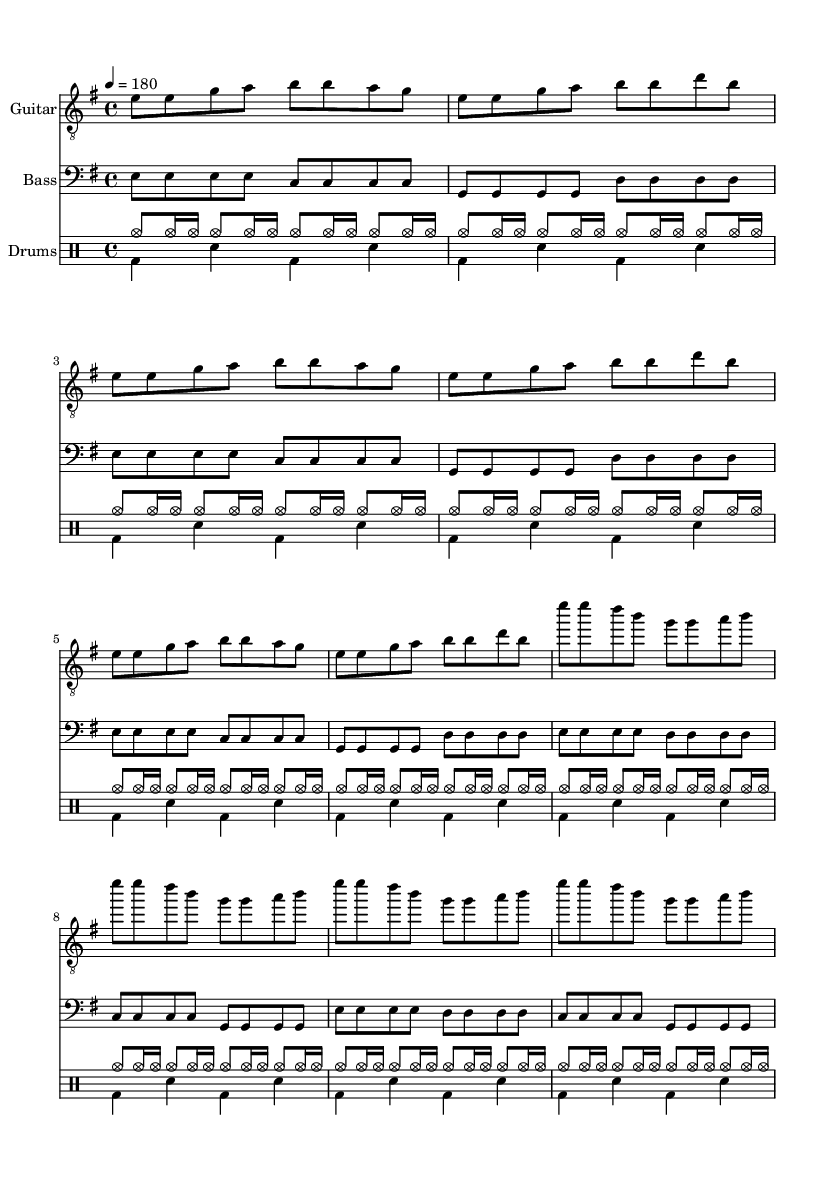What is the key signature of this music? The key signature is E minor, which contains one sharp (F#). This can be identified in the beginning of the music, where the key signature is indicated before the time signature.
Answer: E minor What is the time signature of the piece? The time signature is 4/4, as indicated in the score where it clearly shows the two numbers: 4 on top and 4 on the bottom. This means that there are four beats in a measure, and the quarter note gets one beat.
Answer: 4/4 What is the tempo marking for this music? The tempo marking is 180 beats per minute, indicated in the score at the beginning with the notation "4 = 180". This specifies the speed at which the music should be played.
Answer: 180 How many measures are in the chorus section? There are four measures in the chorus section, which can be counted by observing the repeated music notation and the established structure of the section. Each line of the chorus consists of four bars.
Answer: 4 What instrument plays the introductory melody? The guitar plays the introductory melody, as indicated by its instrument name at the start of the corresponding staff. The guitar section features melodic notes in the treble clef, distinct from the bass and drums.
Answer: Guitar How many times is the verse pattern repeated throughout the verses? The verse pattern is repeated three times throughout the verses; this can be seen in the repeated lines of music for the verses, making it apparent how the structure is established.
Answer: 3 What is the primary musical quality that characterizes this piece as Punk? The primary musical quality that characterizes this piece as Punk is its fast tempo and simple, repetitive structures, both of which are typical features of Punk music, allowing for energetic and raw expression.
Answer: Energetic 